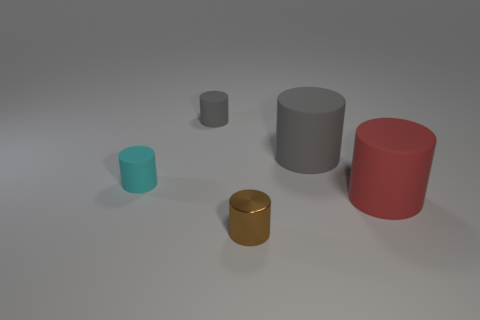The shiny cylinder in front of the big gray cylinder is what color? brown 